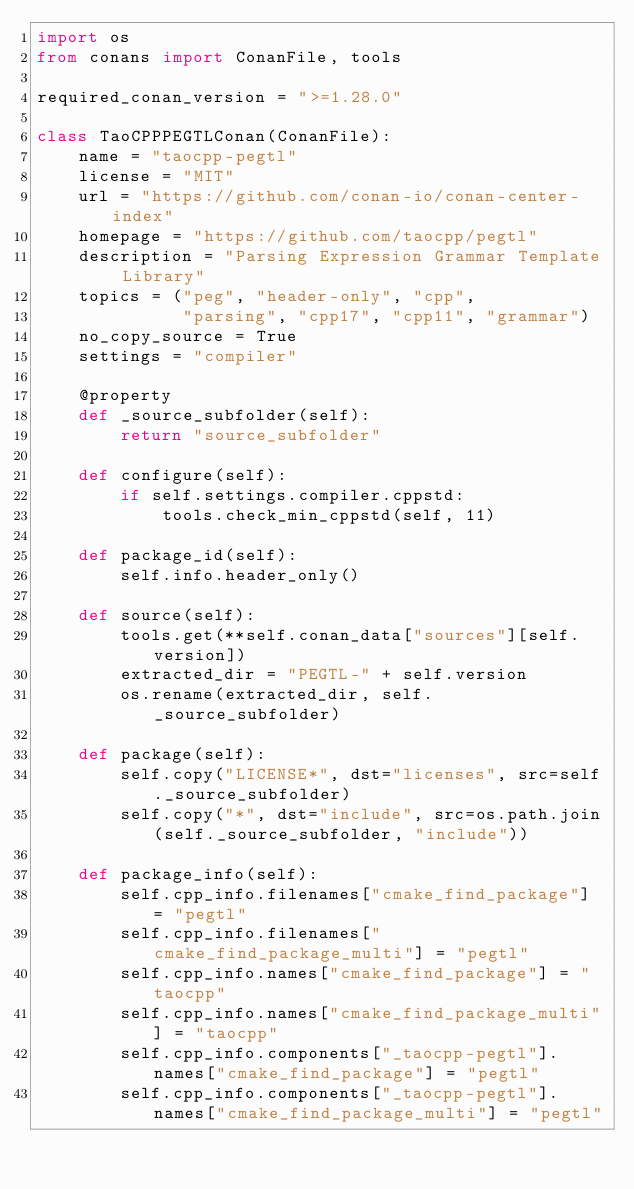Convert code to text. <code><loc_0><loc_0><loc_500><loc_500><_Python_>import os
from conans import ConanFile, tools

required_conan_version = ">=1.28.0"

class TaoCPPPEGTLConan(ConanFile):
    name = "taocpp-pegtl"
    license = "MIT"
    url = "https://github.com/conan-io/conan-center-index"
    homepage = "https://github.com/taocpp/pegtl"
    description = "Parsing Expression Grammar Template Library"
    topics = ("peg", "header-only", "cpp",
              "parsing", "cpp17", "cpp11", "grammar")
    no_copy_source = True
    settings = "compiler"

    @property
    def _source_subfolder(self):
        return "source_subfolder"

    def configure(self):
        if self.settings.compiler.cppstd:
            tools.check_min_cppstd(self, 11)

    def package_id(self):
        self.info.header_only()

    def source(self):
        tools.get(**self.conan_data["sources"][self.version])
        extracted_dir = "PEGTL-" + self.version
        os.rename(extracted_dir, self._source_subfolder)

    def package(self):
        self.copy("LICENSE*", dst="licenses", src=self._source_subfolder)
        self.copy("*", dst="include", src=os.path.join(self._source_subfolder, "include"))

    def package_info(self):
        self.cpp_info.filenames["cmake_find_package"] = "pegtl"
        self.cpp_info.filenames["cmake_find_package_multi"] = "pegtl"
        self.cpp_info.names["cmake_find_package"] = "taocpp"
        self.cpp_info.names["cmake_find_package_multi"] = "taocpp"
        self.cpp_info.components["_taocpp-pegtl"].names["cmake_find_package"] = "pegtl"
        self.cpp_info.components["_taocpp-pegtl"].names["cmake_find_package_multi"] = "pegtl"
</code> 